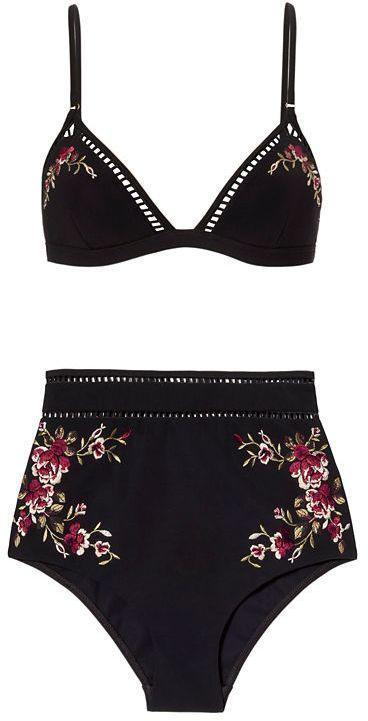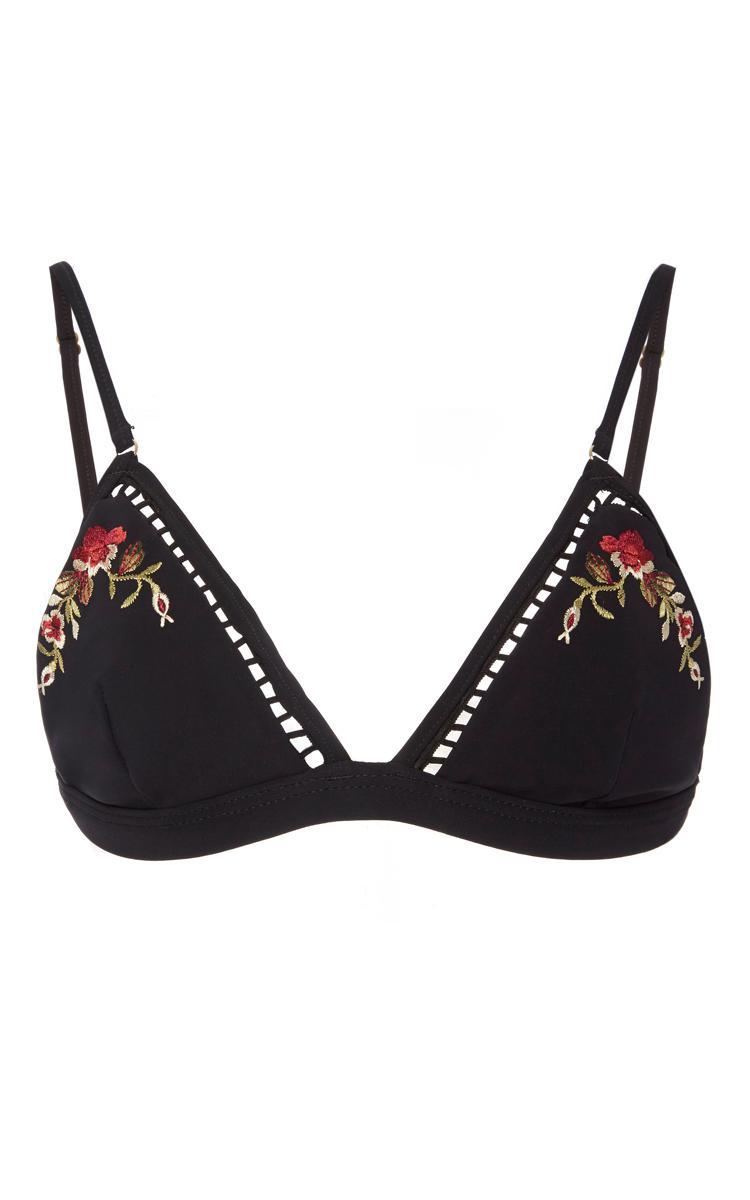The first image is the image on the left, the second image is the image on the right. Considering the images on both sides, is "the bathing suit in one of the images features a tie on bikini top." valid? Answer yes or no. No. 